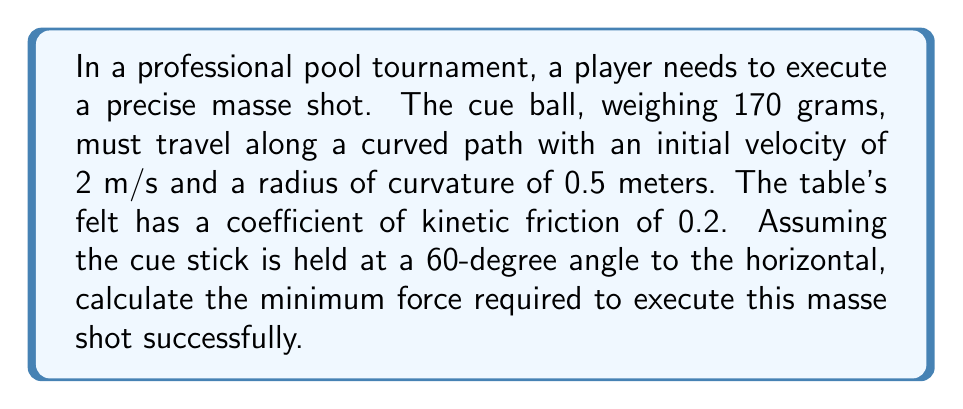Solve this math problem. To solve this problem, we'll use vector calculus and consider the forces acting on the cue ball during the masse shot.

Step 1: Identify the forces
The forces acting on the cue ball are:
1. Friction force ($$\vec{F_f}$$)
2. Normal force ($$\vec{N}$$)
3. Centripetal force ($$\vec{F_c}$$)
4. Applied force from the cue stick ($$\vec{F_a}$$)

Step 2: Set up the coordinate system
Let's use a cylindrical coordinate system ($$r$$, $$\theta$$, $$z$$) with the origin at the center of the circular path.

Step 3: Express the velocity vector
The velocity vector in cylindrical coordinates is:
$$\vec{v} = v\hat{\theta} = 2\hat{\theta}$$ m/s

Step 4: Calculate the centripetal acceleration
The centripetal acceleration is given by:
$$a_c = \frac{v^2}{r} = \frac{2^2}{0.5} = 8$$ m/s²

Step 5: Calculate the centripetal force
$$F_c = ma_c = 0.170 \cdot 8 = 1.36$$ N

Step 6: Calculate the normal force
The normal force is equal to the weight of the ball:
$$N = mg = 0.170 \cdot 9.81 = 1.67$$ N

Step 7: Calculate the friction force
$$F_f = \mu N = 0.2 \cdot 1.67 = 0.334$$ N

Step 8: Determine the required applied force
The applied force must overcome both the centripetal force and the friction force. Using vector addition:

$$\vec{F_a} = \vec{F_c} + \vec{F_f}$$

The magnitude of the applied force is:
$$F_a = \sqrt{F_c^2 + F_f^2} = \sqrt{1.36^2 + 0.334^2} = 1.40$$ N

Step 9: Account for the cue stick angle
Since the cue stick is at a 60-degree angle, we need to adjust the force:

$$F_{required} = \frac{F_a}{\sin(60°)} = \frac{1.40}{0.866} = 1.62$$ N

Therefore, the minimum force required to execute this masse shot successfully is 1.62 N.
Answer: 1.62 N 